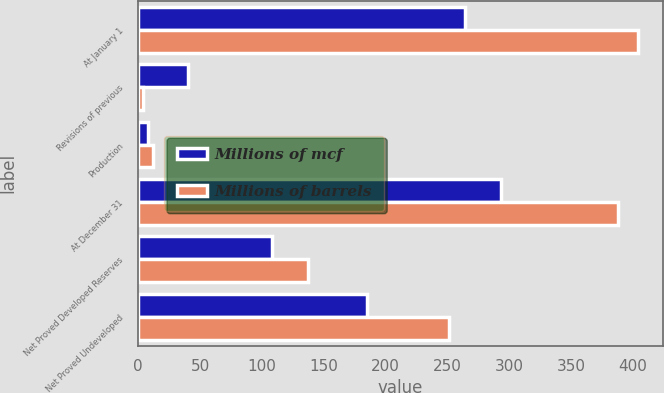Convert chart. <chart><loc_0><loc_0><loc_500><loc_500><stacked_bar_chart><ecel><fcel>At January 1<fcel>Revisions of previous<fcel>Production<fcel>At December 31<fcel>Net Proved Developed Reserves<fcel>Net Proved Undeveloped<nl><fcel>Millions of mcf<fcel>264<fcel>40<fcel>8<fcel>293<fcel>108<fcel>185<nl><fcel>Millions of barrels<fcel>404<fcel>4<fcel>12<fcel>388<fcel>137<fcel>251<nl></chart> 